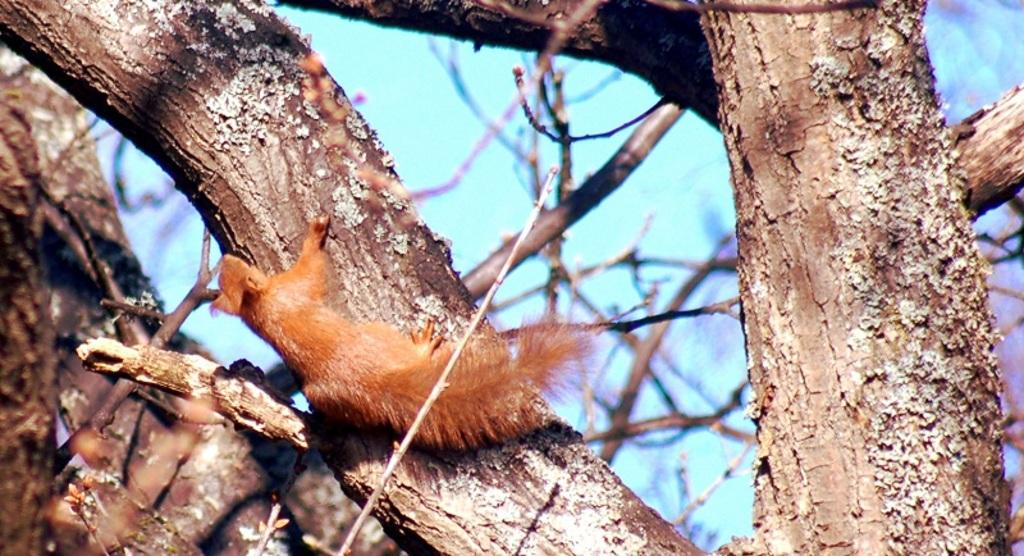What animal is present in the image? There is a squirrel in the image. Where is the squirrel located? The squirrel is on a tree. What can be seen in the background of the image? There is sky visible in the background of the image. Is the squirrel holding a bike in the image? No, the squirrel is not holding a bike in the image. Is there a cabbage growing on the tree with the squirrel? No, there is no cabbage present in the image. 